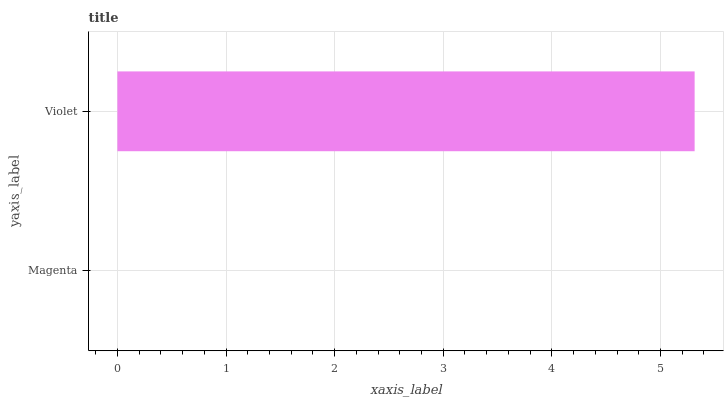Is Magenta the minimum?
Answer yes or no. Yes. Is Violet the maximum?
Answer yes or no. Yes. Is Violet the minimum?
Answer yes or no. No. Is Violet greater than Magenta?
Answer yes or no. Yes. Is Magenta less than Violet?
Answer yes or no. Yes. Is Magenta greater than Violet?
Answer yes or no. No. Is Violet less than Magenta?
Answer yes or no. No. Is Violet the high median?
Answer yes or no. Yes. Is Magenta the low median?
Answer yes or no. Yes. Is Magenta the high median?
Answer yes or no. No. Is Violet the low median?
Answer yes or no. No. 